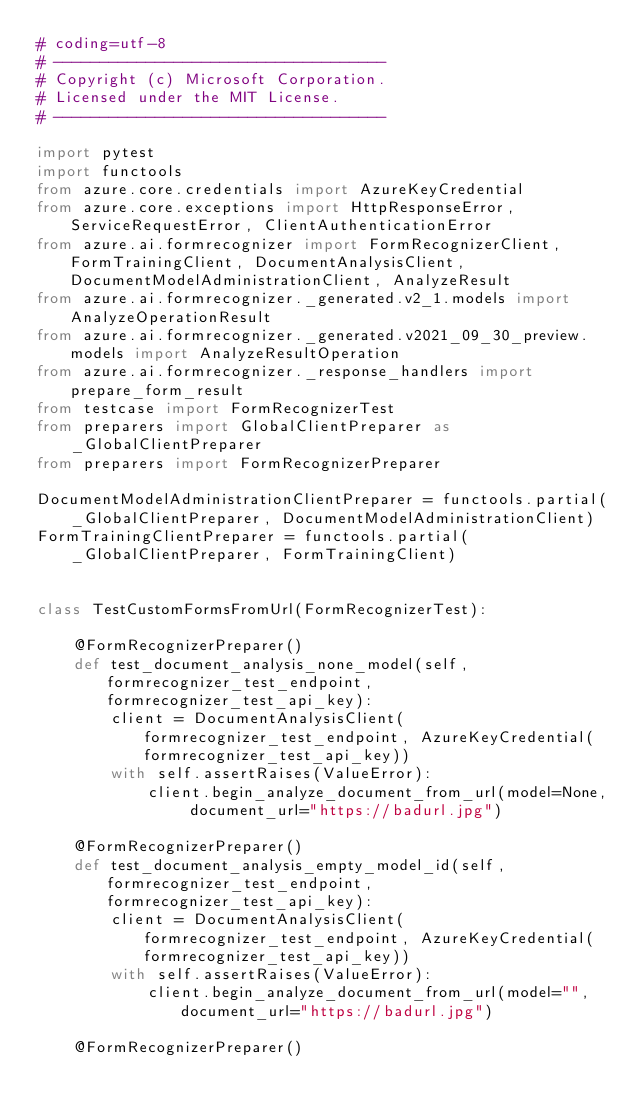Convert code to text. <code><loc_0><loc_0><loc_500><loc_500><_Python_># coding=utf-8
# ------------------------------------
# Copyright (c) Microsoft Corporation.
# Licensed under the MIT License.
# ------------------------------------

import pytest
import functools
from azure.core.credentials import AzureKeyCredential
from azure.core.exceptions import HttpResponseError, ServiceRequestError, ClientAuthenticationError
from azure.ai.formrecognizer import FormRecognizerClient, FormTrainingClient, DocumentAnalysisClient, DocumentModelAdministrationClient, AnalyzeResult
from azure.ai.formrecognizer._generated.v2_1.models import AnalyzeOperationResult
from azure.ai.formrecognizer._generated.v2021_09_30_preview.models import AnalyzeResultOperation
from azure.ai.formrecognizer._response_handlers import prepare_form_result
from testcase import FormRecognizerTest
from preparers import GlobalClientPreparer as _GlobalClientPreparer
from preparers import FormRecognizerPreparer

DocumentModelAdministrationClientPreparer = functools.partial(_GlobalClientPreparer, DocumentModelAdministrationClient)
FormTrainingClientPreparer = functools.partial(_GlobalClientPreparer, FormTrainingClient)


class TestCustomFormsFromUrl(FormRecognizerTest):

    @FormRecognizerPreparer()
    def test_document_analysis_none_model(self, formrecognizer_test_endpoint, formrecognizer_test_api_key):
        client = DocumentAnalysisClient(formrecognizer_test_endpoint, AzureKeyCredential(formrecognizer_test_api_key))
        with self.assertRaises(ValueError):
            client.begin_analyze_document_from_url(model=None, document_url="https://badurl.jpg")

    @FormRecognizerPreparer()
    def test_document_analysis_empty_model_id(self, formrecognizer_test_endpoint, formrecognizer_test_api_key):
        client = DocumentAnalysisClient(formrecognizer_test_endpoint, AzureKeyCredential(formrecognizer_test_api_key))
        with self.assertRaises(ValueError):
            client.begin_analyze_document_from_url(model="", document_url="https://badurl.jpg")

    @FormRecognizerPreparer()</code> 